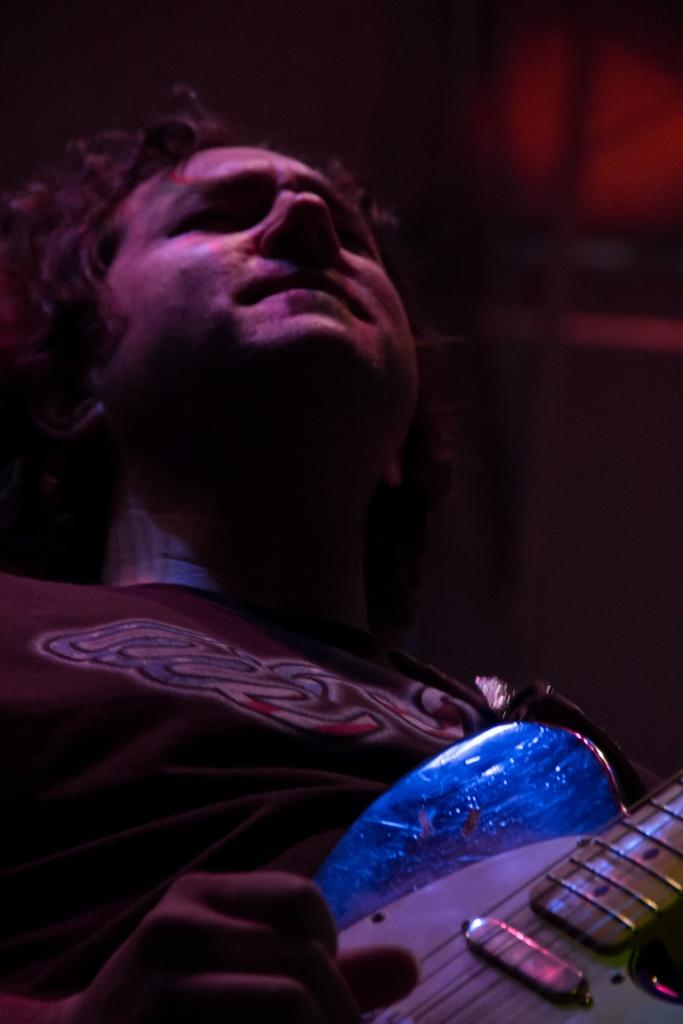What is the main subject of the image? There is a person in the image. What is the person holding in the image? The person is holding a guitar. What type of bushes can be heard in the background of the image? There are no bushes present in the image, and therefore no sound can be attributed to them. 